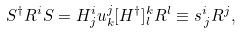Convert formula to latex. <formula><loc_0><loc_0><loc_500><loc_500>S ^ { \dagger } R ^ { i } S = H ^ { i } _ { j } u ^ { j } _ { k } [ H ^ { \dagger } ] ^ { k } _ { l } R ^ { l } \equiv s ^ { i } _ { \, j } R ^ { j } ,</formula> 